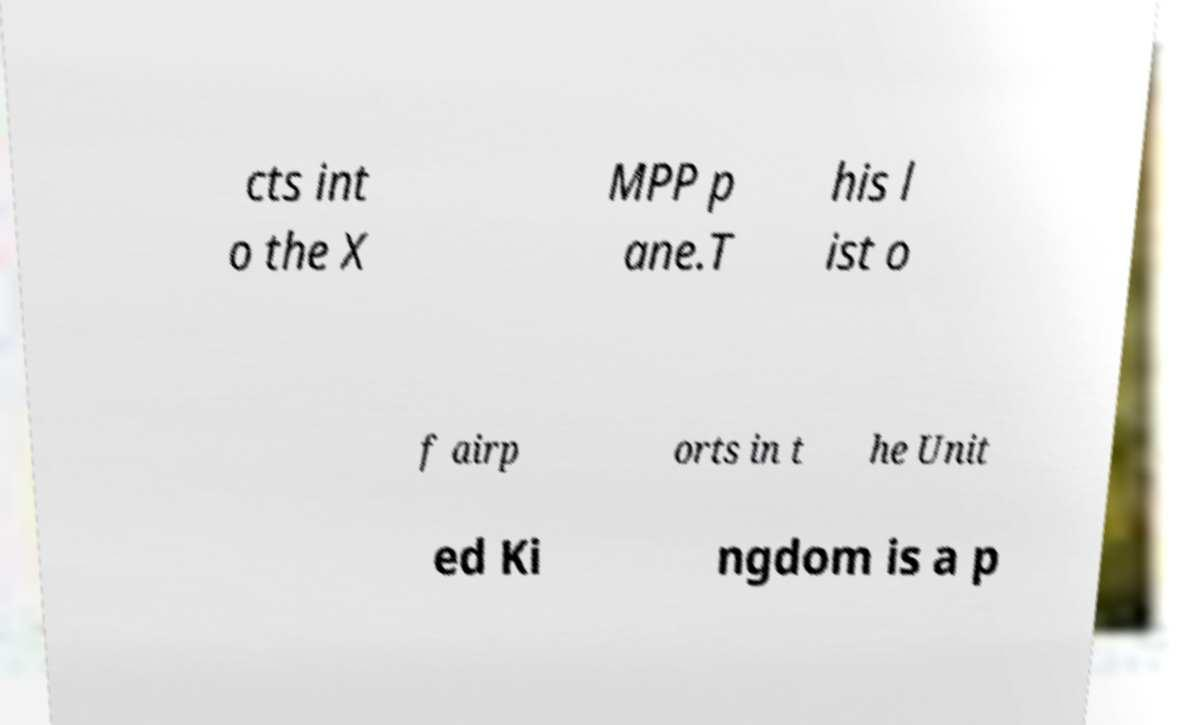Please read and relay the text visible in this image. What does it say? cts int o the X MPP p ane.T his l ist o f airp orts in t he Unit ed Ki ngdom is a p 